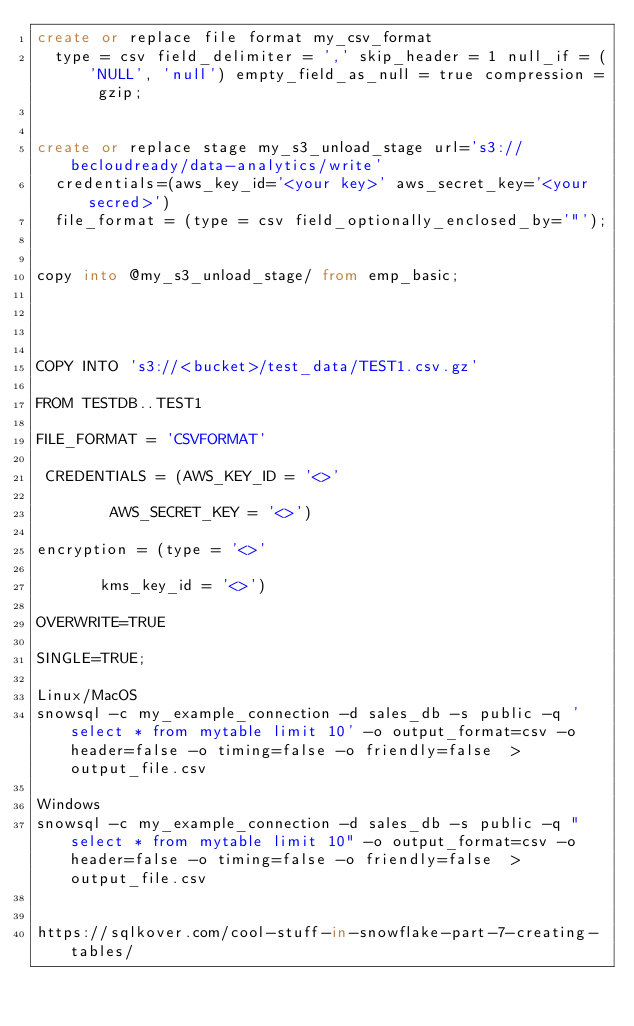<code> <loc_0><loc_0><loc_500><loc_500><_SQL_>create or replace file format my_csv_format
  type = csv field_delimiter = ',' skip_header = 1 null_if = ('NULL', 'null') empty_field_as_null = true compression = gzip;


create or replace stage my_s3_unload_stage url='s3://becloudready/data-analytics/write'
  credentials=(aws_key_id='<your key>' aws_secret_key='<your secred>')
  file_format = (type = csv field_optionally_enclosed_by='"');


copy into @my_s3_unload_stage/ from emp_basic;




COPY INTO 's3://<bucket>/test_data/TEST1.csv.gz'

FROM TESTDB..TEST1

FILE_FORMAT = 'CSVFORMAT'

 CREDENTIALS = (AWS_KEY_ID = '<>'

        AWS_SECRET_KEY = '<>')

encryption = (type = '<>'

       kms_key_id = '<>')

OVERWRITE=TRUE

SINGLE=TRUE;

Linux/MacOS
snowsql -c my_example_connection -d sales_db -s public -q 'select * from mytable limit 10' -o output_format=csv -o header=false -o timing=false -o friendly=false  > output_file.csv

Windows
snowsql -c my_example_connection -d sales_db -s public -q "select * from mytable limit 10" -o output_format=csv -o header=false -o timing=false -o friendly=false  > output_file.csv


https://sqlkover.com/cool-stuff-in-snowflake-part-7-creating-tables/</code> 